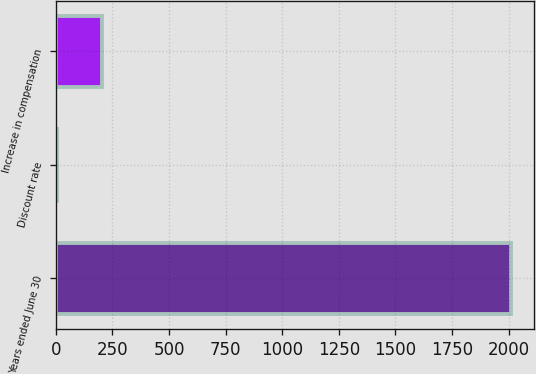<chart> <loc_0><loc_0><loc_500><loc_500><bar_chart><fcel>Years ended June 30<fcel>Discount rate<fcel>Increase in compensation<nl><fcel>2012<fcel>3.9<fcel>204.71<nl></chart> 